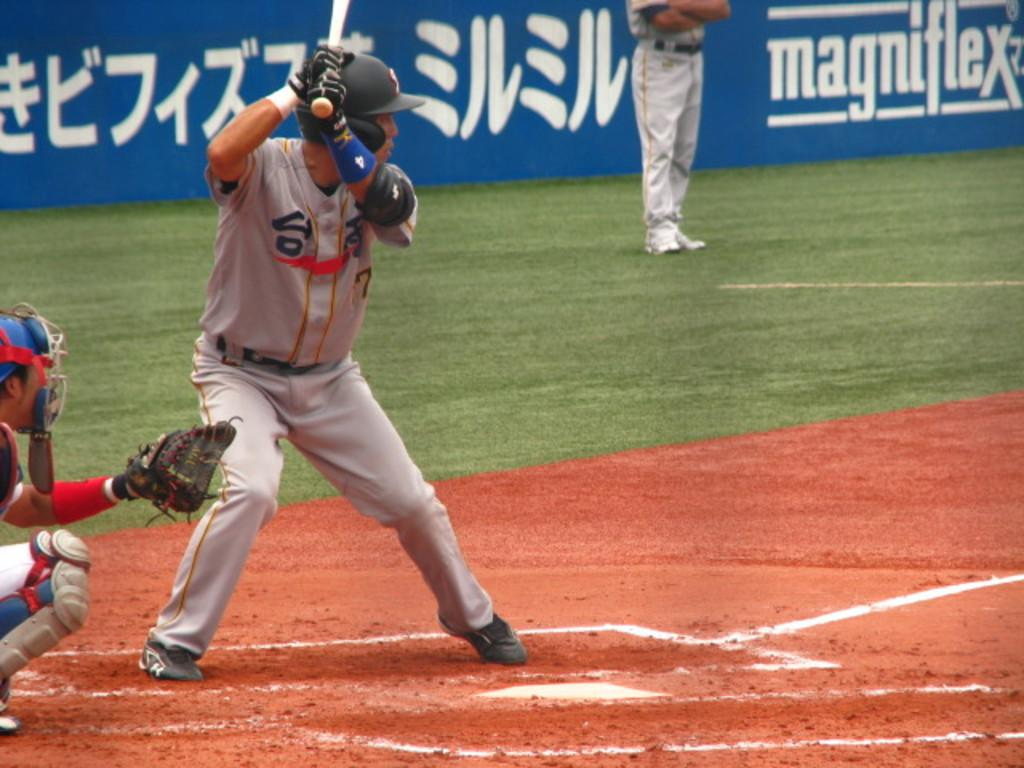<image>
Present a compact description of the photo's key features. Player number 7 is up at bat and he hold the bat in position. 